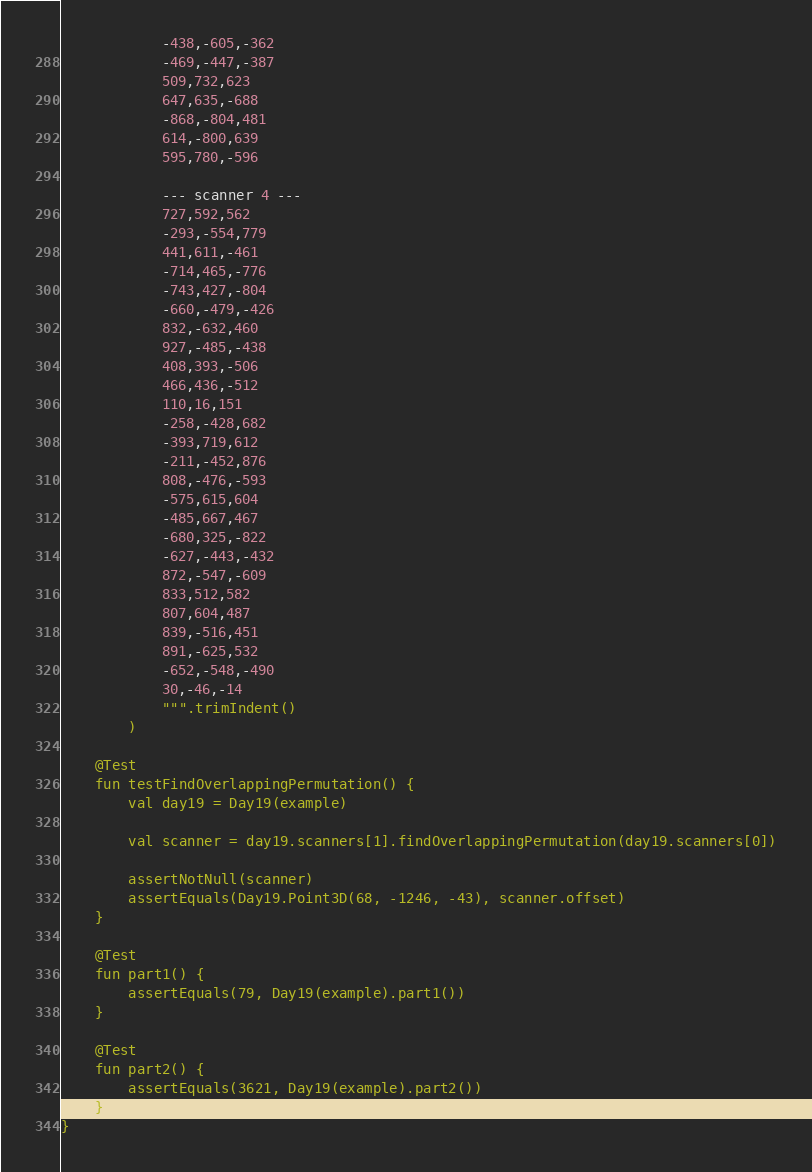<code> <loc_0><loc_0><loc_500><loc_500><_Kotlin_>            -438,-605,-362
            -469,-447,-387
            509,732,623
            647,635,-688
            -868,-804,481
            614,-800,639
            595,780,-596

            --- scanner 4 ---
            727,592,562
            -293,-554,779
            441,611,-461
            -714,465,-776
            -743,427,-804
            -660,-479,-426
            832,-632,460
            927,-485,-438
            408,393,-506
            466,436,-512
            110,16,151
            -258,-428,682
            -393,719,612
            -211,-452,876
            808,-476,-593
            -575,615,604
            -485,667,467
            -680,325,-822
            -627,-443,-432
            872,-547,-609
            833,512,582
            807,604,487
            839,-516,451
            891,-625,532
            -652,-548,-490
            30,-46,-14
            """.trimIndent()
        )

    @Test
    fun testFindOverlappingPermutation() {
        val day19 = Day19(example)

        val scanner = day19.scanners[1].findOverlappingPermutation(day19.scanners[0])

        assertNotNull(scanner)
        assertEquals(Day19.Point3D(68, -1246, -43), scanner.offset)
    }

    @Test
    fun part1() {
        assertEquals(79, Day19(example).part1())
    }

    @Test
    fun part2() {
        assertEquals(3621, Day19(example).part2())
    }
}</code> 